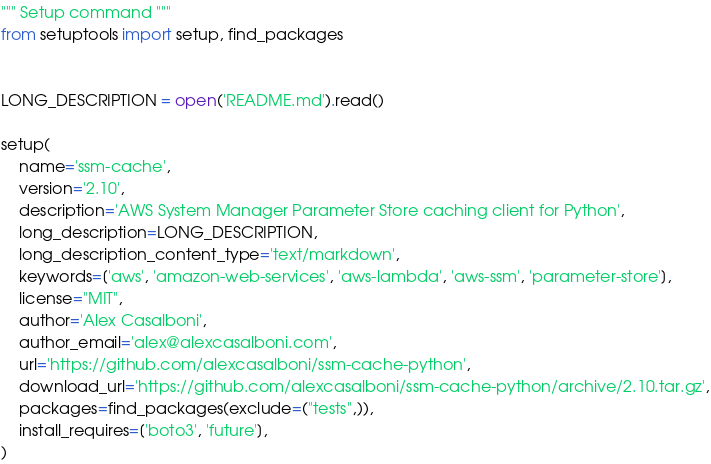Convert code to text. <code><loc_0><loc_0><loc_500><loc_500><_Python_>""" Setup command """
from setuptools import setup, find_packages


LONG_DESCRIPTION = open('README.md').read()

setup(
    name='ssm-cache',
    version='2.10',
    description='AWS System Manager Parameter Store caching client for Python',
    long_description=LONG_DESCRIPTION,
    long_description_content_type='text/markdown',
    keywords=['aws', 'amazon-web-services', 'aws-lambda', 'aws-ssm', 'parameter-store'],
    license="MIT",
    author='Alex Casalboni',
    author_email='alex@alexcasalboni.com',
    url='https://github.com/alexcasalboni/ssm-cache-python',
    download_url='https://github.com/alexcasalboni/ssm-cache-python/archive/2.10.tar.gz',
    packages=find_packages(exclude=("tests",)),
    install_requires=['boto3', 'future'],
)
</code> 